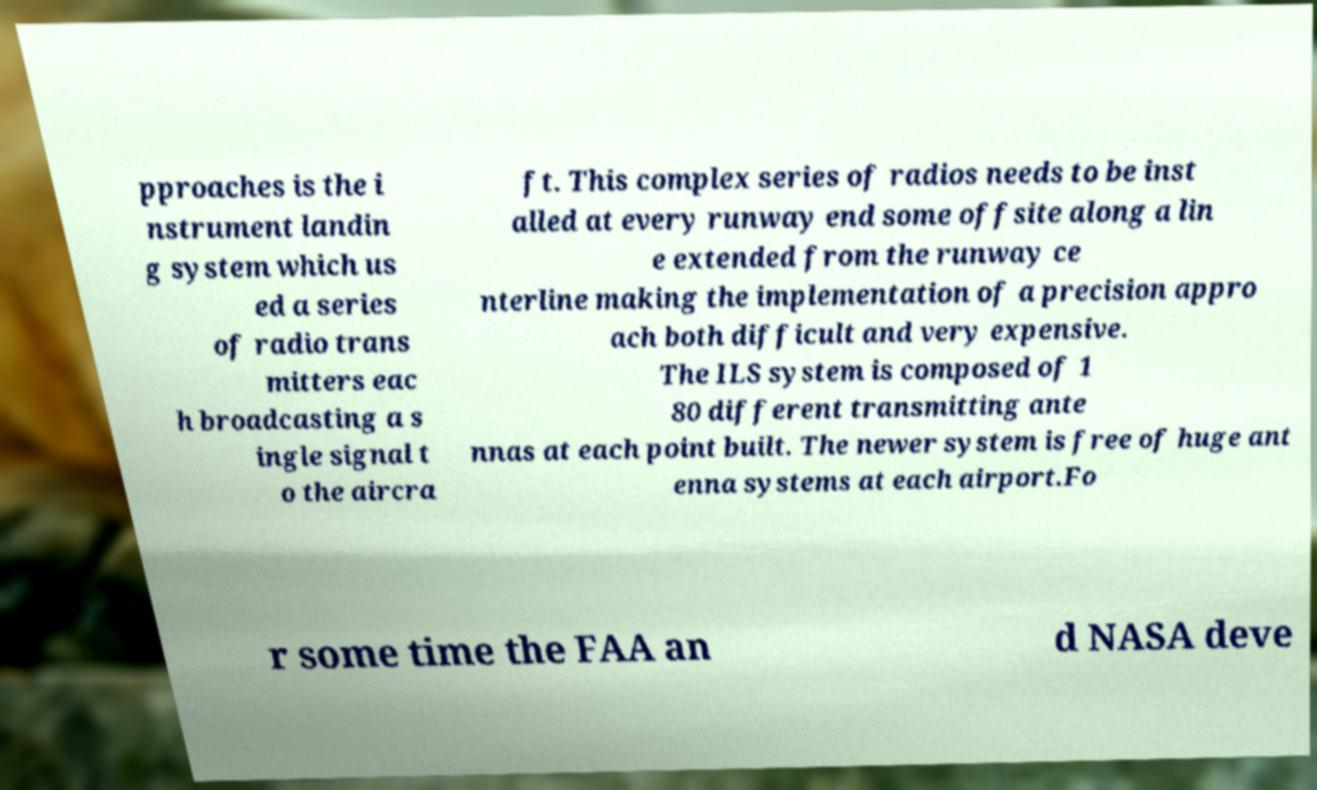Could you assist in decoding the text presented in this image and type it out clearly? pproaches is the i nstrument landin g system which us ed a series of radio trans mitters eac h broadcasting a s ingle signal t o the aircra ft. This complex series of radios needs to be inst alled at every runway end some offsite along a lin e extended from the runway ce nterline making the implementation of a precision appro ach both difficult and very expensive. The ILS system is composed of 1 80 different transmitting ante nnas at each point built. The newer system is free of huge ant enna systems at each airport.Fo r some time the FAA an d NASA deve 